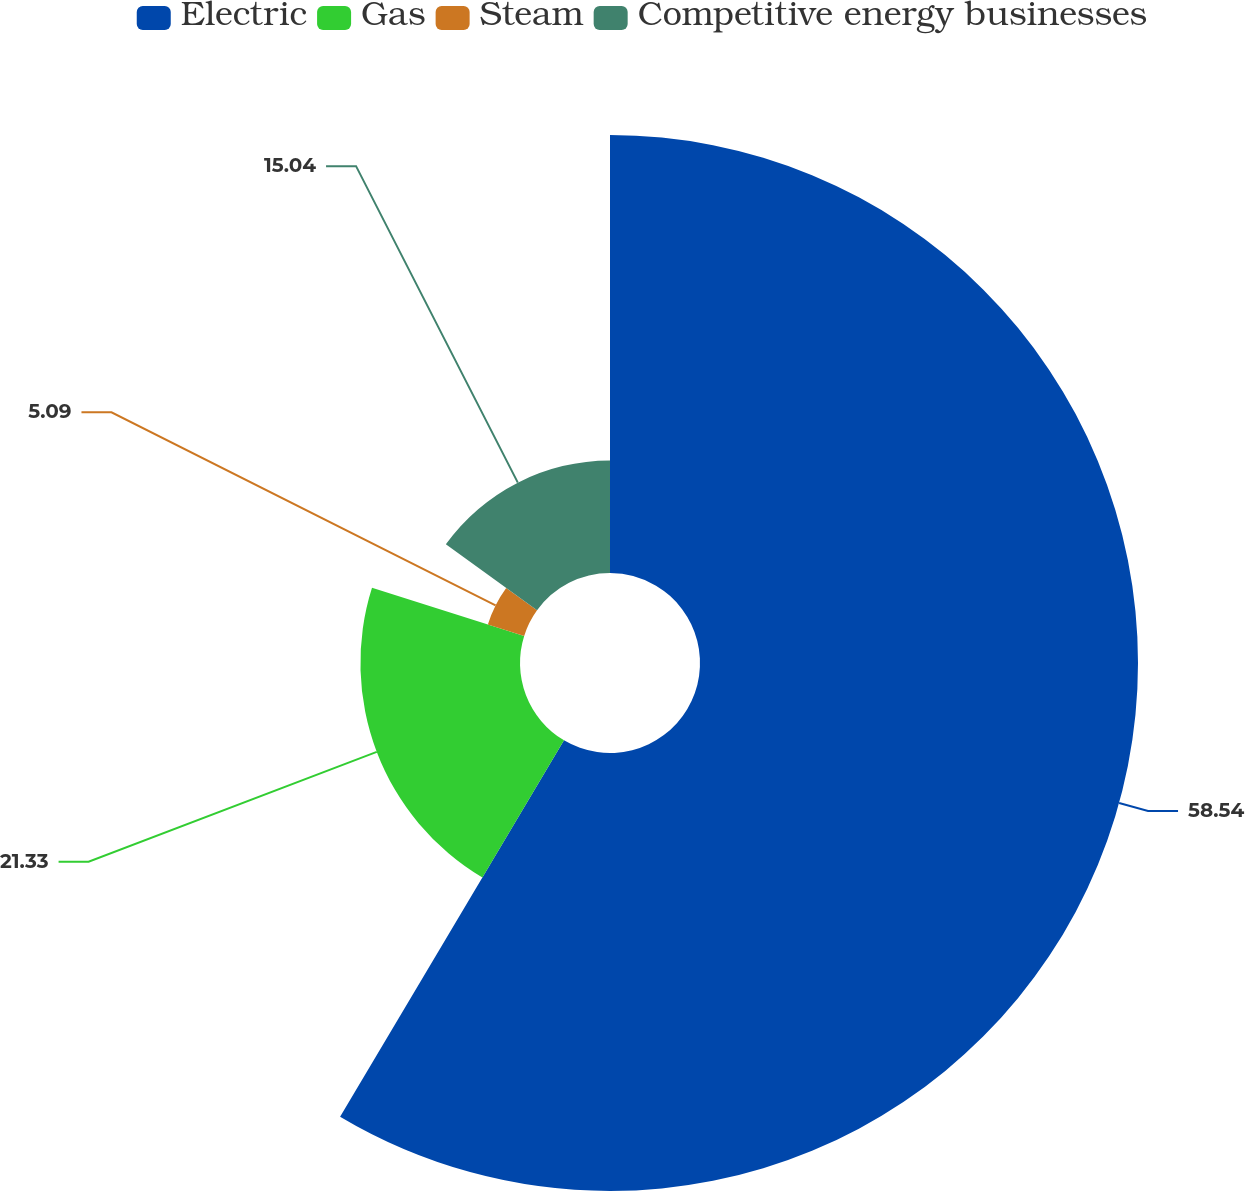Convert chart to OTSL. <chart><loc_0><loc_0><loc_500><loc_500><pie_chart><fcel>Electric<fcel>Gas<fcel>Steam<fcel>Competitive energy businesses<nl><fcel>58.54%<fcel>21.33%<fcel>5.09%<fcel>15.04%<nl></chart> 